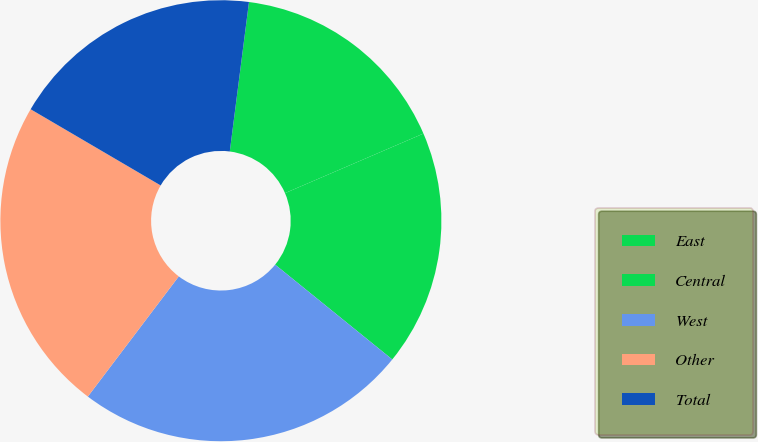<chart> <loc_0><loc_0><loc_500><loc_500><pie_chart><fcel>East<fcel>Central<fcel>West<fcel>Other<fcel>Total<nl><fcel>16.5%<fcel>17.3%<fcel>24.48%<fcel>23.13%<fcel>18.6%<nl></chart> 